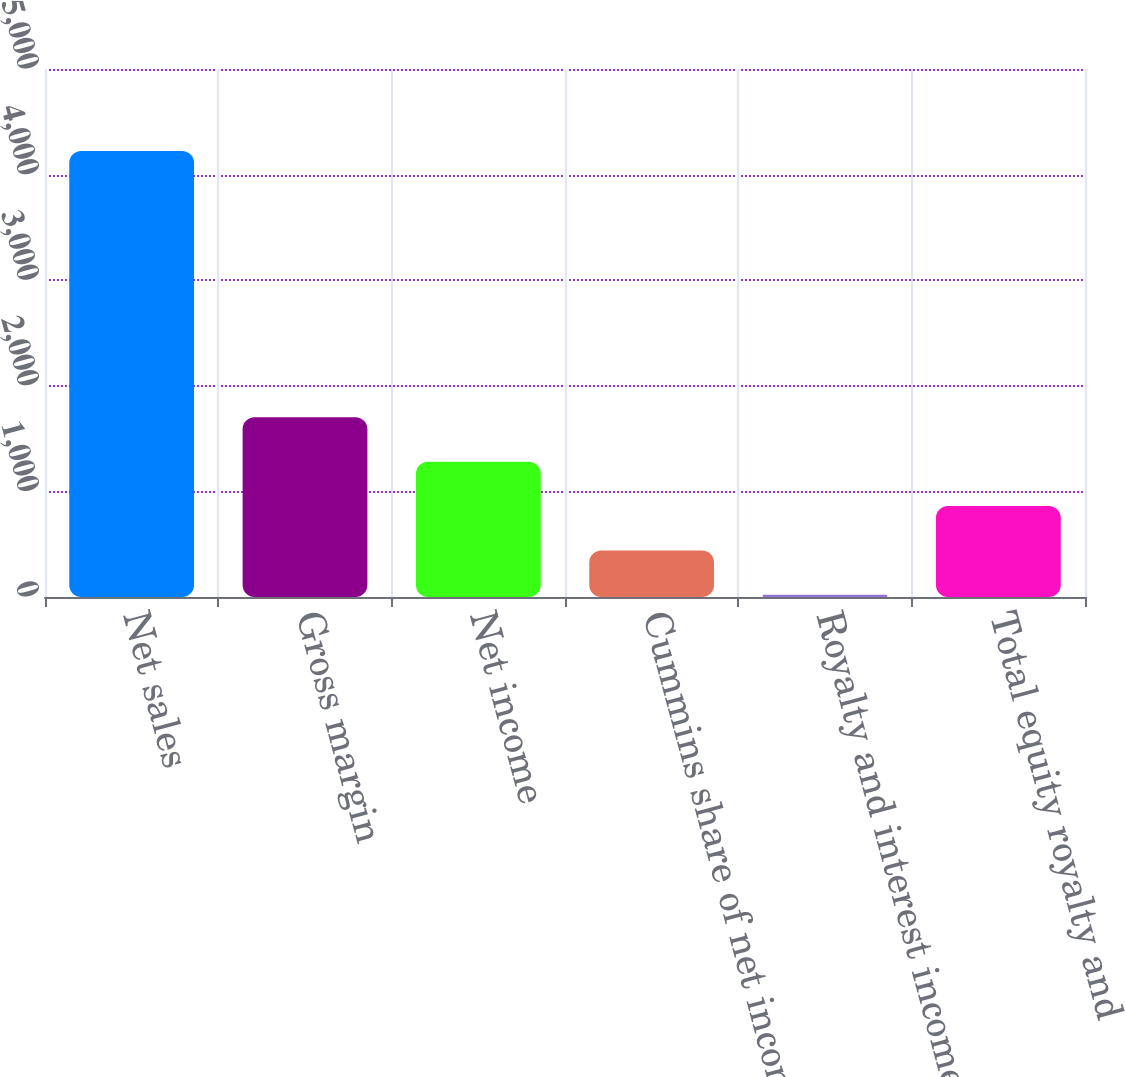Convert chart to OTSL. <chart><loc_0><loc_0><loc_500><loc_500><bar_chart><fcel>Net sales<fcel>Gross margin<fcel>Net income<fcel>Cummins share of net income<fcel>Royalty and interest income<fcel>Total equity royalty and<nl><fcel>4224<fcel>1702.2<fcel>1281.9<fcel>441.3<fcel>21<fcel>861.6<nl></chart> 